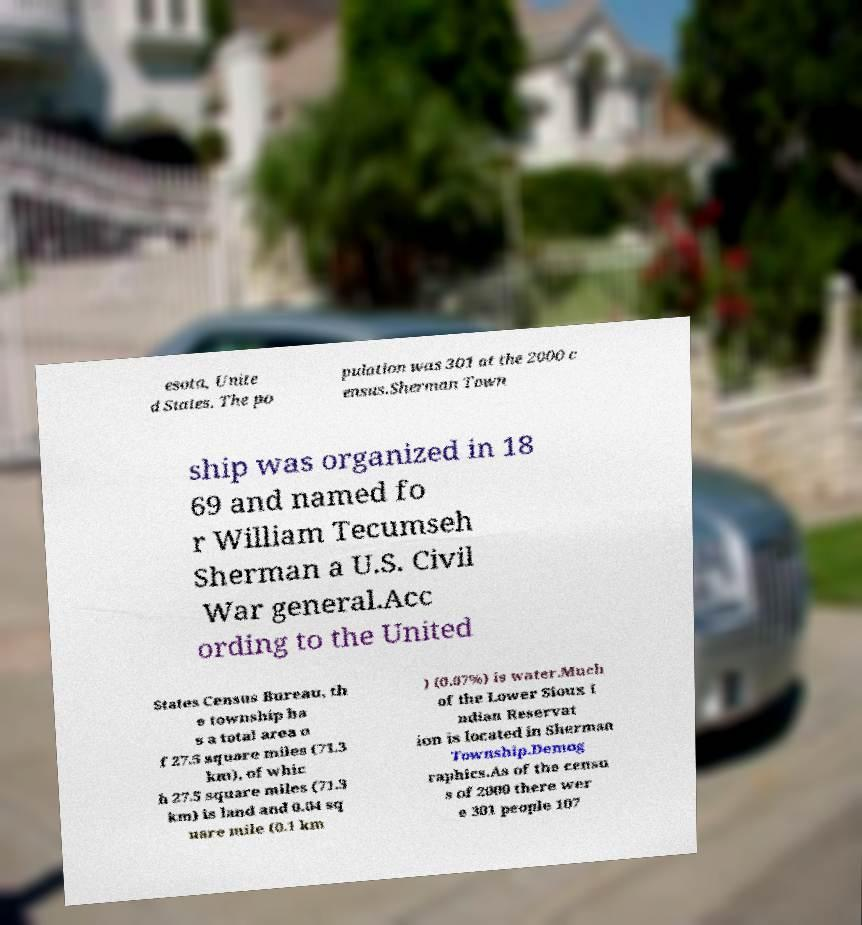Please identify and transcribe the text found in this image. esota, Unite d States. The po pulation was 301 at the 2000 c ensus.Sherman Town ship was organized in 18 69 and named fo r William Tecumseh Sherman a U.S. Civil War general.Acc ording to the United States Census Bureau, th e township ha s a total area o f 27.5 square miles (71.3 km), of whic h 27.5 square miles (71.3 km) is land and 0.04 sq uare mile (0.1 km ) (0.07%) is water.Much of the Lower Sioux I ndian Reservat ion is located in Sherman Township.Demog raphics.As of the censu s of 2000 there wer e 301 people 107 